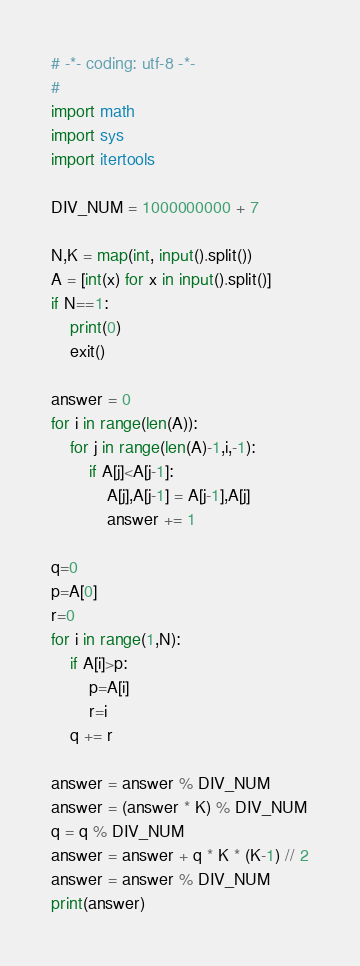Convert code to text. <code><loc_0><loc_0><loc_500><loc_500><_Python_># -*- coding: utf-8 -*-
# 
import math
import sys
import itertools

DIV_NUM = 1000000000 + 7

N,K = map(int, input().split())
A = [int(x) for x in input().split()]
if N==1:
    print(0)
    exit()

answer = 0
for i in range(len(A)):
    for j in range(len(A)-1,i,-1):
        if A[j]<A[j-1]:
            A[j],A[j-1] = A[j-1],A[j]
            answer += 1

q=0
p=A[0]
r=0
for i in range(1,N):
    if A[i]>p:
        p=A[i]
        r=i
    q += r

answer = answer % DIV_NUM
answer = (answer * K) % DIV_NUM
q = q % DIV_NUM
answer = answer + q * K * (K-1) // 2
answer = answer % DIV_NUM
print(answer)

</code> 